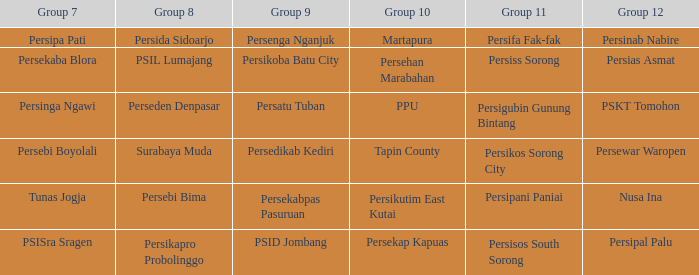Who played in group 12 when persikutim east kutai played in group 10? Nusa Ina. 